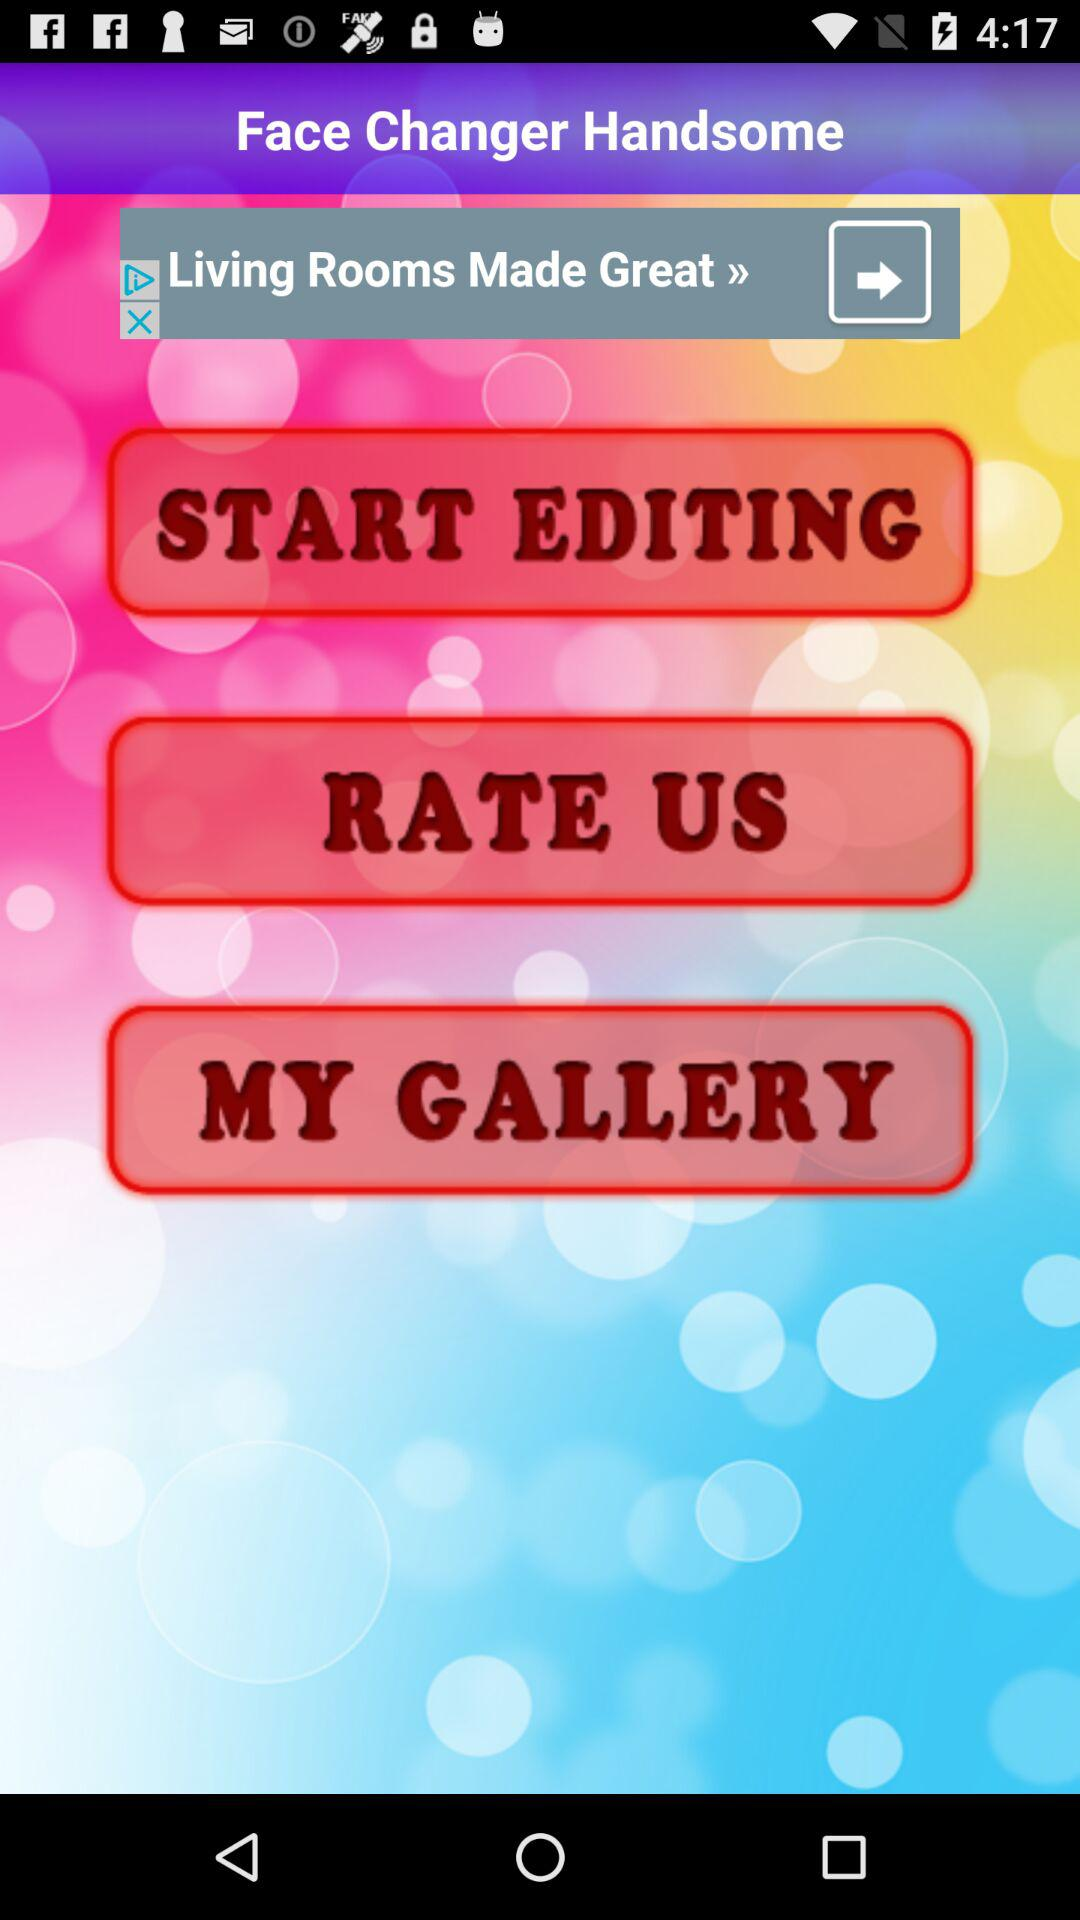What is the name of the application? The application name is "Face Changer Handsome". 